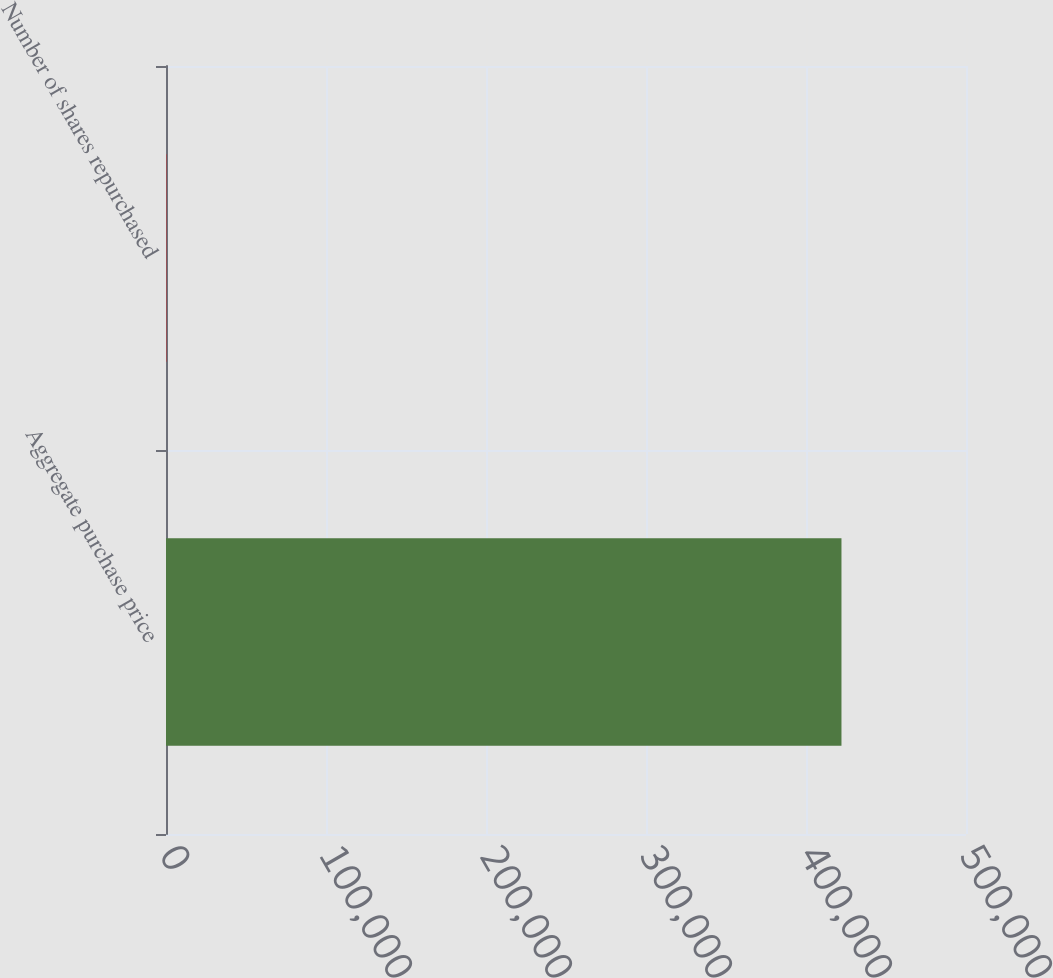<chart> <loc_0><loc_0><loc_500><loc_500><bar_chart><fcel>Aggregate purchase price<fcel>Number of shares repurchased<nl><fcel>422166<fcel>167<nl></chart> 